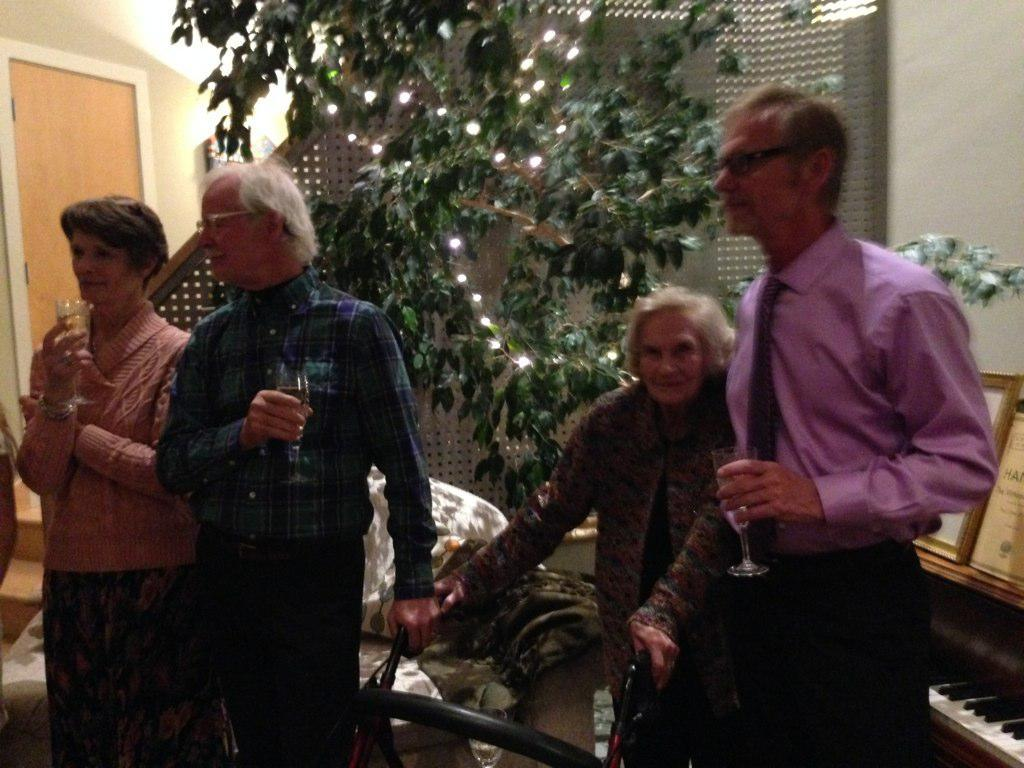How many people are in the image? There are four people in the image. Can you describe the gender of the people in the image? Two of the people are women, and two are men. What can be seen in the background of the image? There is a tree in the background of the image. How are the lights arranged on the tree in the background? The lights are arranged on the tree in the background. What type of wilderness can be seen in the image? There is no wilderness present in the image; it features four people and a tree with lights in the background. How fast are the people running in the image? The people are not running in the image; they are standing or sitting. 